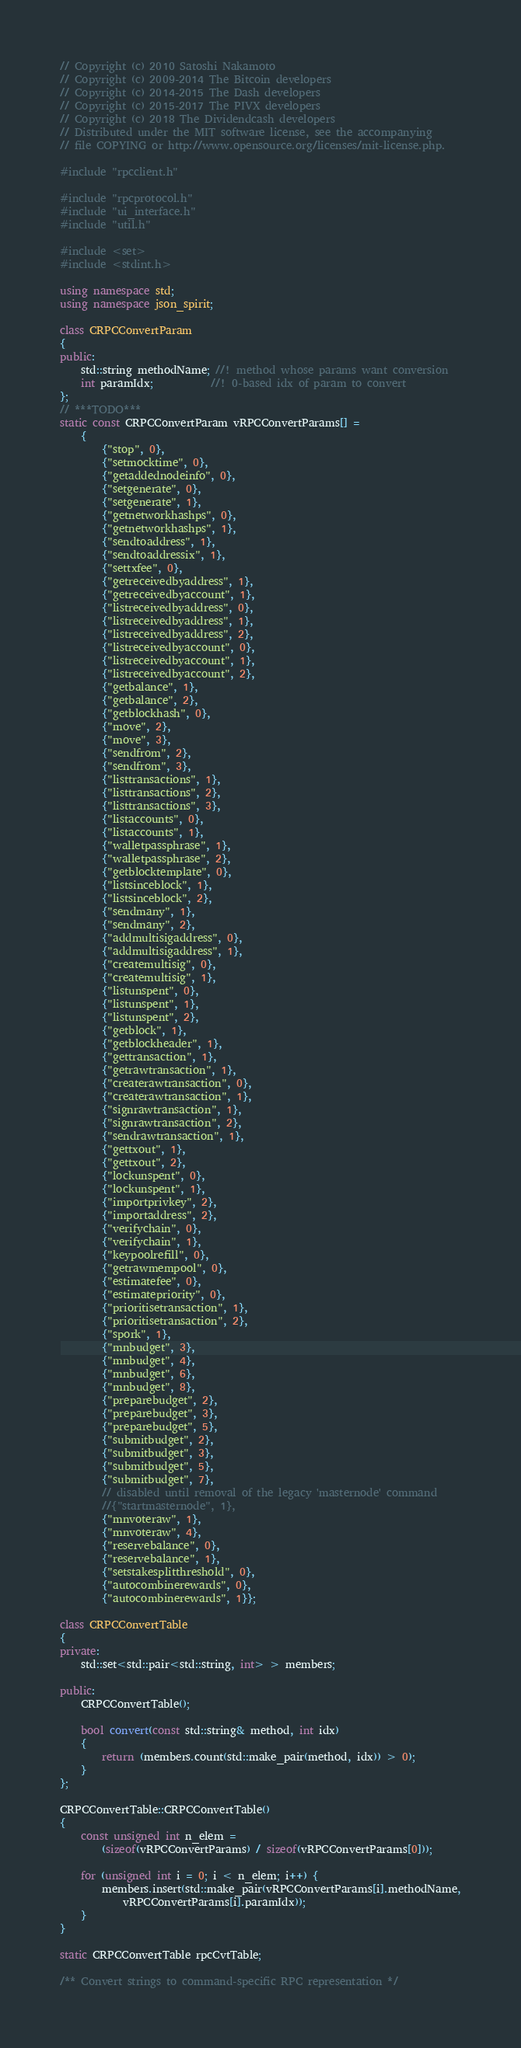Convert code to text. <code><loc_0><loc_0><loc_500><loc_500><_C++_>// Copyright (c) 2010 Satoshi Nakamoto
// Copyright (c) 2009-2014 The Bitcoin developers
// Copyright (c) 2014-2015 The Dash developers
// Copyright (c) 2015-2017 The PIVX developers
// Copyright (c) 2018 The Dividendcash developers
// Distributed under the MIT software license, see the accompanying
// file COPYING or http://www.opensource.org/licenses/mit-license.php.

#include "rpcclient.h"

#include "rpcprotocol.h"
#include "ui_interface.h"
#include "util.h"

#include <set>
#include <stdint.h>

using namespace std;
using namespace json_spirit;

class CRPCConvertParam
{
public:
    std::string methodName; //! method whose params want conversion
    int paramIdx;           //! 0-based idx of param to convert
};
// ***TODO***
static const CRPCConvertParam vRPCConvertParams[] =
    {
        {"stop", 0},
        {"setmocktime", 0},
        {"getaddednodeinfo", 0},
        {"setgenerate", 0},
        {"setgenerate", 1},
        {"getnetworkhashps", 0},
        {"getnetworkhashps", 1},
        {"sendtoaddress", 1},
        {"sendtoaddressix", 1},
        {"settxfee", 0},
        {"getreceivedbyaddress", 1},
        {"getreceivedbyaccount", 1},
        {"listreceivedbyaddress", 0},
        {"listreceivedbyaddress", 1},
        {"listreceivedbyaddress", 2},
        {"listreceivedbyaccount", 0},
        {"listreceivedbyaccount", 1},
        {"listreceivedbyaccount", 2},
        {"getbalance", 1},
        {"getbalance", 2},
        {"getblockhash", 0},
        {"move", 2},
        {"move", 3},
        {"sendfrom", 2},
        {"sendfrom", 3},
        {"listtransactions", 1},
        {"listtransactions", 2},
        {"listtransactions", 3},
        {"listaccounts", 0},
        {"listaccounts", 1},
        {"walletpassphrase", 1},
        {"walletpassphrase", 2},
        {"getblocktemplate", 0},
        {"listsinceblock", 1},
        {"listsinceblock", 2},
        {"sendmany", 1},
        {"sendmany", 2},
        {"addmultisigaddress", 0},
        {"addmultisigaddress", 1},
        {"createmultisig", 0},
        {"createmultisig", 1},
        {"listunspent", 0},
        {"listunspent", 1},
        {"listunspent", 2},
        {"getblock", 1},
        {"getblockheader", 1},
        {"gettransaction", 1},
        {"getrawtransaction", 1},
        {"createrawtransaction", 0},
        {"createrawtransaction", 1},
        {"signrawtransaction", 1},
        {"signrawtransaction", 2},
        {"sendrawtransaction", 1},
        {"gettxout", 1},
        {"gettxout", 2},
        {"lockunspent", 0},
        {"lockunspent", 1},
        {"importprivkey", 2},
        {"importaddress", 2},
        {"verifychain", 0},
        {"verifychain", 1},
        {"keypoolrefill", 0},
        {"getrawmempool", 0},
        {"estimatefee", 0},
        {"estimatepriority", 0},
        {"prioritisetransaction", 1},
        {"prioritisetransaction", 2},
        {"spork", 1},
        {"mnbudget", 3},
        {"mnbudget", 4},
        {"mnbudget", 6},
        {"mnbudget", 8},
        {"preparebudget", 2},
        {"preparebudget", 3},
        {"preparebudget", 5},
        {"submitbudget", 2},
        {"submitbudget", 3},
        {"submitbudget", 5},
        {"submitbudget", 7},
        // disabled until removal of the legacy 'masternode' command
        //{"startmasternode", 1},
        {"mnvoteraw", 1},
        {"mnvoteraw", 4},
        {"reservebalance", 0},
        {"reservebalance", 1},
        {"setstakesplitthreshold", 0},
        {"autocombinerewards", 0},
        {"autocombinerewards", 1}};

class CRPCConvertTable
{
private:
    std::set<std::pair<std::string, int> > members;

public:
    CRPCConvertTable();

    bool convert(const std::string& method, int idx)
    {
        return (members.count(std::make_pair(method, idx)) > 0);
    }
};

CRPCConvertTable::CRPCConvertTable()
{
    const unsigned int n_elem =
        (sizeof(vRPCConvertParams) / sizeof(vRPCConvertParams[0]));

    for (unsigned int i = 0; i < n_elem; i++) {
        members.insert(std::make_pair(vRPCConvertParams[i].methodName,
            vRPCConvertParams[i].paramIdx));
    }
}

static CRPCConvertTable rpcCvtTable;

/** Convert strings to command-specific RPC representation */</code> 